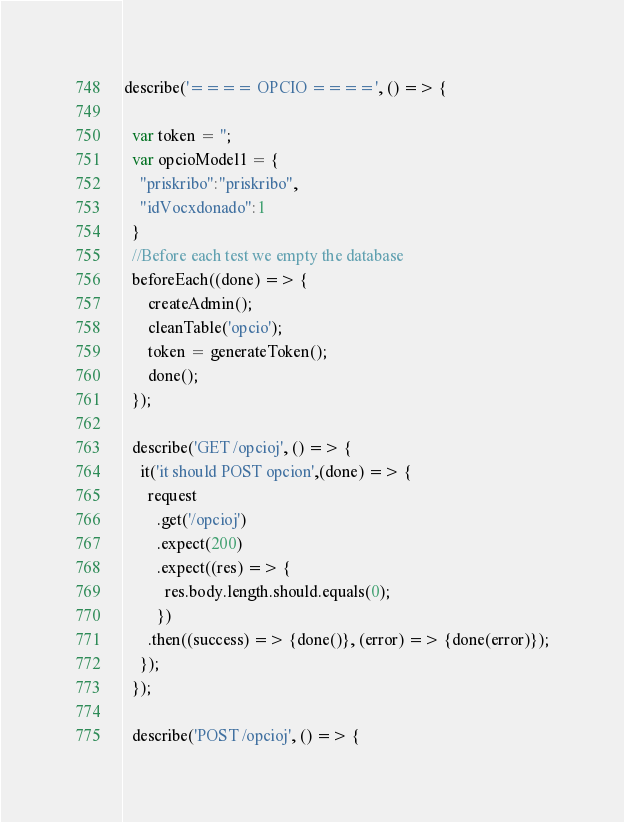<code> <loc_0><loc_0><loc_500><loc_500><_JavaScript_>describe('==== OPCIO ====', () => {

  var token = '';
  var opcioModel1 = {
    "priskribo":"priskribo",
    "idVocxdonado":1
  }
  //Before each test we empty the database
  beforeEach((done) => {
      createAdmin();
      cleanTable('opcio');
      token = generateToken();
      done();
  });

  describe('GET /opcioj', () => {
    it('it should POST opcion',(done) => {
      request
        .get('/opcioj')
        .expect(200)
        .expect((res) => {
          res.body.length.should.equals(0);
        })
      .then((success) => {done()}, (error) => {done(error)});
    });
  });

  describe('POST /opcioj', () => {</code> 